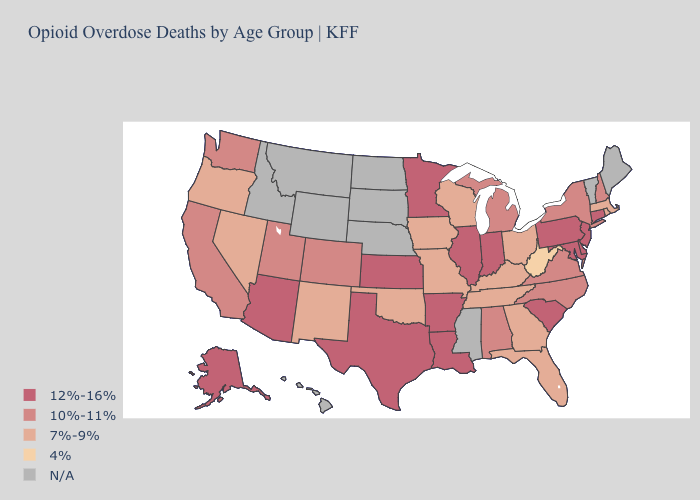Is the legend a continuous bar?
Quick response, please. No. What is the highest value in the South ?
Answer briefly. 12%-16%. Among the states that border North Carolina , which have the highest value?
Concise answer only. South Carolina. Does Colorado have the lowest value in the West?
Short answer required. No. What is the highest value in the USA?
Answer briefly. 12%-16%. Does Wisconsin have the lowest value in the MidWest?
Be succinct. Yes. Among the states that border Kansas , does Missouri have the lowest value?
Short answer required. Yes. Which states have the lowest value in the South?
Give a very brief answer. West Virginia. Name the states that have a value in the range 10%-11%?
Keep it brief. Alabama, California, Colorado, Michigan, New Hampshire, New York, North Carolina, Utah, Virginia, Washington. Among the states that border South Carolina , does Georgia have the lowest value?
Concise answer only. Yes. Name the states that have a value in the range 10%-11%?
Answer briefly. Alabama, California, Colorado, Michigan, New Hampshire, New York, North Carolina, Utah, Virginia, Washington. Does West Virginia have the lowest value in the USA?
Write a very short answer. Yes. Name the states that have a value in the range 7%-9%?
Give a very brief answer. Florida, Georgia, Iowa, Kentucky, Massachusetts, Missouri, Nevada, New Mexico, Ohio, Oklahoma, Oregon, Rhode Island, Tennessee, Wisconsin. Which states have the lowest value in the USA?
Keep it brief. West Virginia. 